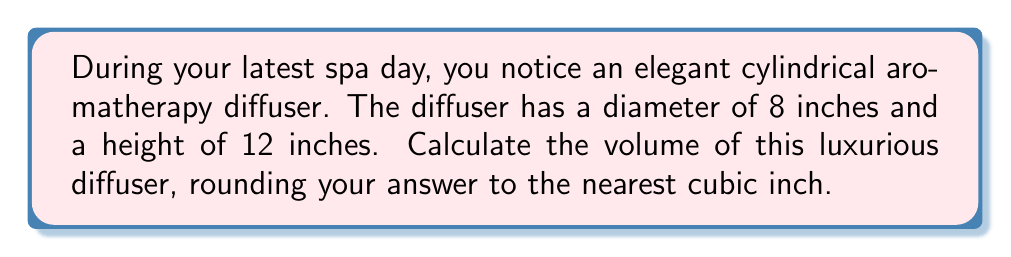Show me your answer to this math problem. Let's approach this step-by-step:

1) The volume of a cylinder is given by the formula:

   $$V = \pi r^2 h$$

   where $V$ is the volume, $r$ is the radius of the base, and $h$ is the height.

2) We're given the diameter (8 inches) and height (12 inches). We need to find the radius:

   $$r = \frac{\text{diameter}}{2} = \frac{8}{2} = 4 \text{ inches}$$

3) Now we can substitute our values into the formula:

   $$V = \pi (4\text{ in})^2 (12\text{ in})$$

4) Let's calculate:

   $$\begin{align*}
   V &= \pi (16\text{ in}^2) (12\text{ in}) \\
   &= 192\pi \text{ in}^3
   \end{align*}$$

5) Using 3.14159 as an approximation for $\pi$:

   $$V \approx 192 * 3.14159 \approx 603.18528 \text{ in}^3$$

6) Rounding to the nearest cubic inch:

   $$V \approx 603 \text{ in}^3$$
Answer: $603 \text{ in}^3$ 